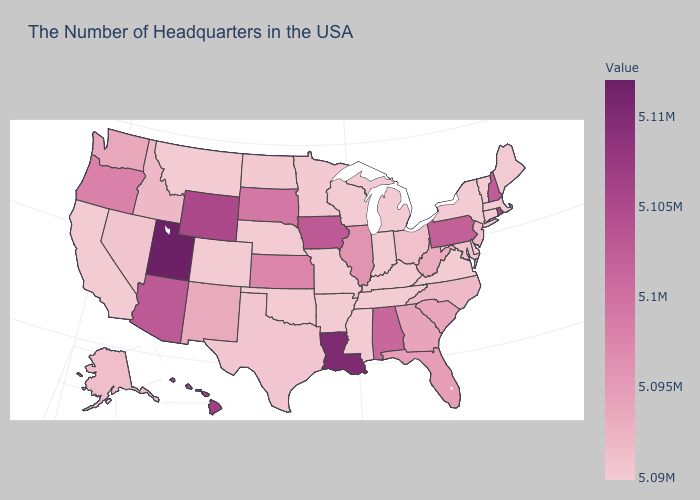Does Delaware have the lowest value in the USA?
Concise answer only. Yes. Which states have the highest value in the USA?
Quick response, please. Utah. Is the legend a continuous bar?
Answer briefly. Yes. 